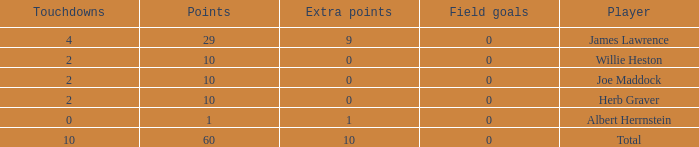What is the highest number of extra points for players with less than 2 touchdowns and less than 1 point? None. 